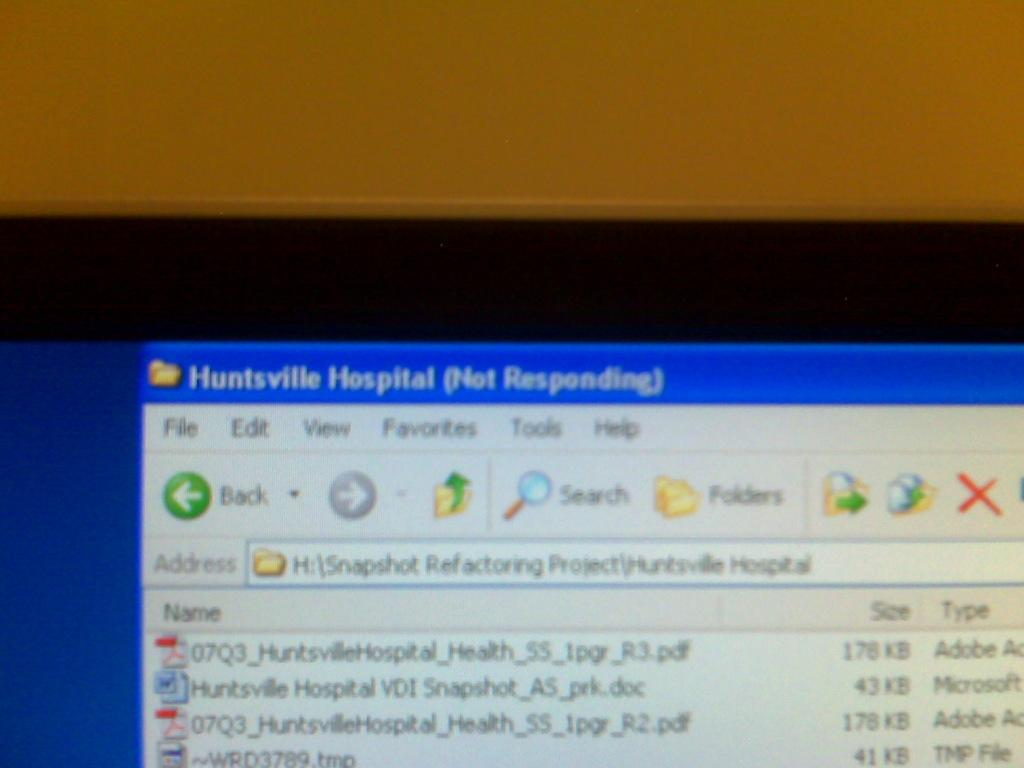Provide a one-sentence caption for the provided image. On the computer, Huntsville Hospital is not reponding. 